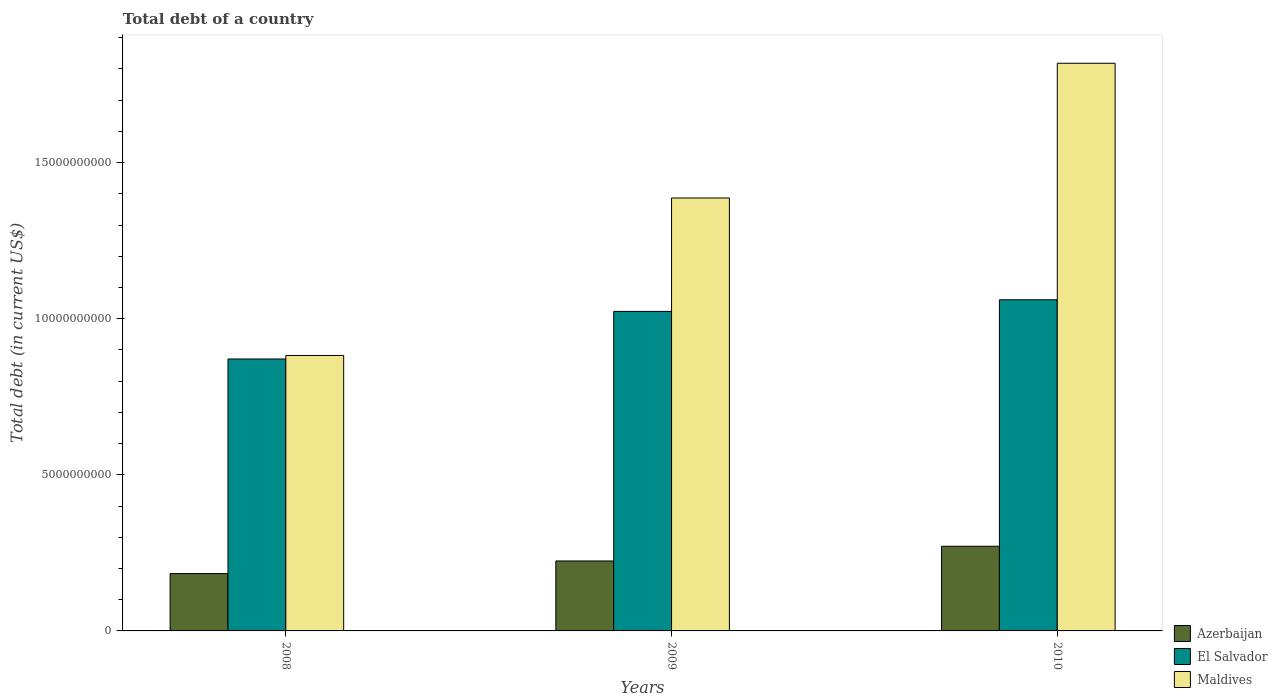How many groups of bars are there?
Offer a terse response. 3. Are the number of bars per tick equal to the number of legend labels?
Provide a succinct answer. Yes. Are the number of bars on each tick of the X-axis equal?
Provide a succinct answer. Yes. How many bars are there on the 1st tick from the right?
Offer a very short reply. 3. What is the label of the 2nd group of bars from the left?
Your answer should be very brief. 2009. In how many cases, is the number of bars for a given year not equal to the number of legend labels?
Give a very brief answer. 0. What is the debt in Azerbaijan in 2009?
Your answer should be very brief. 2.24e+09. Across all years, what is the maximum debt in El Salvador?
Offer a terse response. 1.06e+1. Across all years, what is the minimum debt in Maldives?
Make the answer very short. 8.82e+09. In which year was the debt in Maldives minimum?
Provide a short and direct response. 2008. What is the total debt in Azerbaijan in the graph?
Provide a short and direct response. 6.79e+09. What is the difference between the debt in Azerbaijan in 2008 and that in 2010?
Give a very brief answer. -8.75e+08. What is the difference between the debt in Azerbaijan in 2008 and the debt in El Salvador in 2009?
Give a very brief answer. -8.40e+09. What is the average debt in Maldives per year?
Your response must be concise. 1.36e+1. In the year 2010, what is the difference between the debt in Maldives and debt in Azerbaijan?
Your response must be concise. 1.55e+1. In how many years, is the debt in El Salvador greater than 1000000000 US$?
Make the answer very short. 3. What is the ratio of the debt in Maldives in 2008 to that in 2009?
Your response must be concise. 0.64. Is the debt in El Salvador in 2008 less than that in 2009?
Your response must be concise. Yes. What is the difference between the highest and the second highest debt in Azerbaijan?
Your response must be concise. 4.71e+08. What is the difference between the highest and the lowest debt in Maldives?
Give a very brief answer. 9.36e+09. What does the 1st bar from the left in 2008 represents?
Give a very brief answer. Azerbaijan. What does the 1st bar from the right in 2008 represents?
Ensure brevity in your answer.  Maldives. How many bars are there?
Provide a short and direct response. 9. Are all the bars in the graph horizontal?
Provide a short and direct response. No. What is the difference between two consecutive major ticks on the Y-axis?
Your answer should be very brief. 5.00e+09. Are the values on the major ticks of Y-axis written in scientific E-notation?
Provide a succinct answer. No. Does the graph contain any zero values?
Provide a succinct answer. No. Does the graph contain grids?
Provide a short and direct response. No. Where does the legend appear in the graph?
Provide a succinct answer. Bottom right. How many legend labels are there?
Provide a short and direct response. 3. What is the title of the graph?
Offer a terse response. Total debt of a country. What is the label or title of the X-axis?
Keep it short and to the point. Years. What is the label or title of the Y-axis?
Provide a succinct answer. Total debt (in current US$). What is the Total debt (in current US$) in Azerbaijan in 2008?
Offer a terse response. 1.84e+09. What is the Total debt (in current US$) of El Salvador in 2008?
Your answer should be very brief. 8.71e+09. What is the Total debt (in current US$) in Maldives in 2008?
Your answer should be compact. 8.82e+09. What is the Total debt (in current US$) in Azerbaijan in 2009?
Ensure brevity in your answer.  2.24e+09. What is the Total debt (in current US$) in El Salvador in 2009?
Keep it short and to the point. 1.02e+1. What is the Total debt (in current US$) of Maldives in 2009?
Offer a terse response. 1.39e+1. What is the Total debt (in current US$) in Azerbaijan in 2010?
Provide a succinct answer. 2.71e+09. What is the Total debt (in current US$) in El Salvador in 2010?
Offer a very short reply. 1.06e+1. What is the Total debt (in current US$) in Maldives in 2010?
Give a very brief answer. 1.82e+1. Across all years, what is the maximum Total debt (in current US$) in Azerbaijan?
Ensure brevity in your answer.  2.71e+09. Across all years, what is the maximum Total debt (in current US$) in El Salvador?
Make the answer very short. 1.06e+1. Across all years, what is the maximum Total debt (in current US$) of Maldives?
Ensure brevity in your answer.  1.82e+1. Across all years, what is the minimum Total debt (in current US$) of Azerbaijan?
Offer a very short reply. 1.84e+09. Across all years, what is the minimum Total debt (in current US$) in El Salvador?
Keep it short and to the point. 8.71e+09. Across all years, what is the minimum Total debt (in current US$) in Maldives?
Ensure brevity in your answer.  8.82e+09. What is the total Total debt (in current US$) in Azerbaijan in the graph?
Your answer should be very brief. 6.79e+09. What is the total Total debt (in current US$) of El Salvador in the graph?
Your response must be concise. 2.96e+1. What is the total Total debt (in current US$) in Maldives in the graph?
Make the answer very short. 4.09e+1. What is the difference between the Total debt (in current US$) of Azerbaijan in 2008 and that in 2009?
Offer a very short reply. -4.04e+08. What is the difference between the Total debt (in current US$) in El Salvador in 2008 and that in 2009?
Keep it short and to the point. -1.52e+09. What is the difference between the Total debt (in current US$) of Maldives in 2008 and that in 2009?
Give a very brief answer. -5.04e+09. What is the difference between the Total debt (in current US$) in Azerbaijan in 2008 and that in 2010?
Your response must be concise. -8.75e+08. What is the difference between the Total debt (in current US$) in El Salvador in 2008 and that in 2010?
Ensure brevity in your answer.  -1.90e+09. What is the difference between the Total debt (in current US$) in Maldives in 2008 and that in 2010?
Offer a very short reply. -9.36e+09. What is the difference between the Total debt (in current US$) of Azerbaijan in 2009 and that in 2010?
Your response must be concise. -4.71e+08. What is the difference between the Total debt (in current US$) in El Salvador in 2009 and that in 2010?
Provide a succinct answer. -3.72e+08. What is the difference between the Total debt (in current US$) in Maldives in 2009 and that in 2010?
Ensure brevity in your answer.  -4.32e+09. What is the difference between the Total debt (in current US$) of Azerbaijan in 2008 and the Total debt (in current US$) of El Salvador in 2009?
Offer a very short reply. -8.40e+09. What is the difference between the Total debt (in current US$) in Azerbaijan in 2008 and the Total debt (in current US$) in Maldives in 2009?
Give a very brief answer. -1.20e+1. What is the difference between the Total debt (in current US$) in El Salvador in 2008 and the Total debt (in current US$) in Maldives in 2009?
Your response must be concise. -5.16e+09. What is the difference between the Total debt (in current US$) in Azerbaijan in 2008 and the Total debt (in current US$) in El Salvador in 2010?
Your response must be concise. -8.77e+09. What is the difference between the Total debt (in current US$) of Azerbaijan in 2008 and the Total debt (in current US$) of Maldives in 2010?
Provide a short and direct response. -1.63e+1. What is the difference between the Total debt (in current US$) in El Salvador in 2008 and the Total debt (in current US$) in Maldives in 2010?
Provide a short and direct response. -9.47e+09. What is the difference between the Total debt (in current US$) of Azerbaijan in 2009 and the Total debt (in current US$) of El Salvador in 2010?
Make the answer very short. -8.37e+09. What is the difference between the Total debt (in current US$) of Azerbaijan in 2009 and the Total debt (in current US$) of Maldives in 2010?
Provide a succinct answer. -1.59e+1. What is the difference between the Total debt (in current US$) in El Salvador in 2009 and the Total debt (in current US$) in Maldives in 2010?
Provide a short and direct response. -7.95e+09. What is the average Total debt (in current US$) in Azerbaijan per year?
Provide a succinct answer. 2.26e+09. What is the average Total debt (in current US$) of El Salvador per year?
Ensure brevity in your answer.  9.85e+09. What is the average Total debt (in current US$) of Maldives per year?
Your response must be concise. 1.36e+1. In the year 2008, what is the difference between the Total debt (in current US$) of Azerbaijan and Total debt (in current US$) of El Salvador?
Make the answer very short. -6.87e+09. In the year 2008, what is the difference between the Total debt (in current US$) in Azerbaijan and Total debt (in current US$) in Maldives?
Your answer should be very brief. -6.99e+09. In the year 2008, what is the difference between the Total debt (in current US$) in El Salvador and Total debt (in current US$) in Maldives?
Offer a terse response. -1.12e+08. In the year 2009, what is the difference between the Total debt (in current US$) in Azerbaijan and Total debt (in current US$) in El Salvador?
Your response must be concise. -7.99e+09. In the year 2009, what is the difference between the Total debt (in current US$) of Azerbaijan and Total debt (in current US$) of Maldives?
Keep it short and to the point. -1.16e+1. In the year 2009, what is the difference between the Total debt (in current US$) in El Salvador and Total debt (in current US$) in Maldives?
Provide a succinct answer. -3.63e+09. In the year 2010, what is the difference between the Total debt (in current US$) in Azerbaijan and Total debt (in current US$) in El Salvador?
Your response must be concise. -7.89e+09. In the year 2010, what is the difference between the Total debt (in current US$) in Azerbaijan and Total debt (in current US$) in Maldives?
Your response must be concise. -1.55e+1. In the year 2010, what is the difference between the Total debt (in current US$) in El Salvador and Total debt (in current US$) in Maldives?
Your answer should be compact. -7.58e+09. What is the ratio of the Total debt (in current US$) of Azerbaijan in 2008 to that in 2009?
Your answer should be compact. 0.82. What is the ratio of the Total debt (in current US$) in El Salvador in 2008 to that in 2009?
Offer a terse response. 0.85. What is the ratio of the Total debt (in current US$) in Maldives in 2008 to that in 2009?
Make the answer very short. 0.64. What is the ratio of the Total debt (in current US$) of Azerbaijan in 2008 to that in 2010?
Offer a very short reply. 0.68. What is the ratio of the Total debt (in current US$) in El Salvador in 2008 to that in 2010?
Make the answer very short. 0.82. What is the ratio of the Total debt (in current US$) of Maldives in 2008 to that in 2010?
Your answer should be very brief. 0.49. What is the ratio of the Total debt (in current US$) in Azerbaijan in 2009 to that in 2010?
Your response must be concise. 0.83. What is the ratio of the Total debt (in current US$) in El Salvador in 2009 to that in 2010?
Provide a short and direct response. 0.96. What is the ratio of the Total debt (in current US$) in Maldives in 2009 to that in 2010?
Your answer should be very brief. 0.76. What is the difference between the highest and the second highest Total debt (in current US$) of Azerbaijan?
Make the answer very short. 4.71e+08. What is the difference between the highest and the second highest Total debt (in current US$) in El Salvador?
Your answer should be very brief. 3.72e+08. What is the difference between the highest and the second highest Total debt (in current US$) in Maldives?
Provide a short and direct response. 4.32e+09. What is the difference between the highest and the lowest Total debt (in current US$) in Azerbaijan?
Provide a succinct answer. 8.75e+08. What is the difference between the highest and the lowest Total debt (in current US$) in El Salvador?
Offer a very short reply. 1.90e+09. What is the difference between the highest and the lowest Total debt (in current US$) of Maldives?
Offer a terse response. 9.36e+09. 